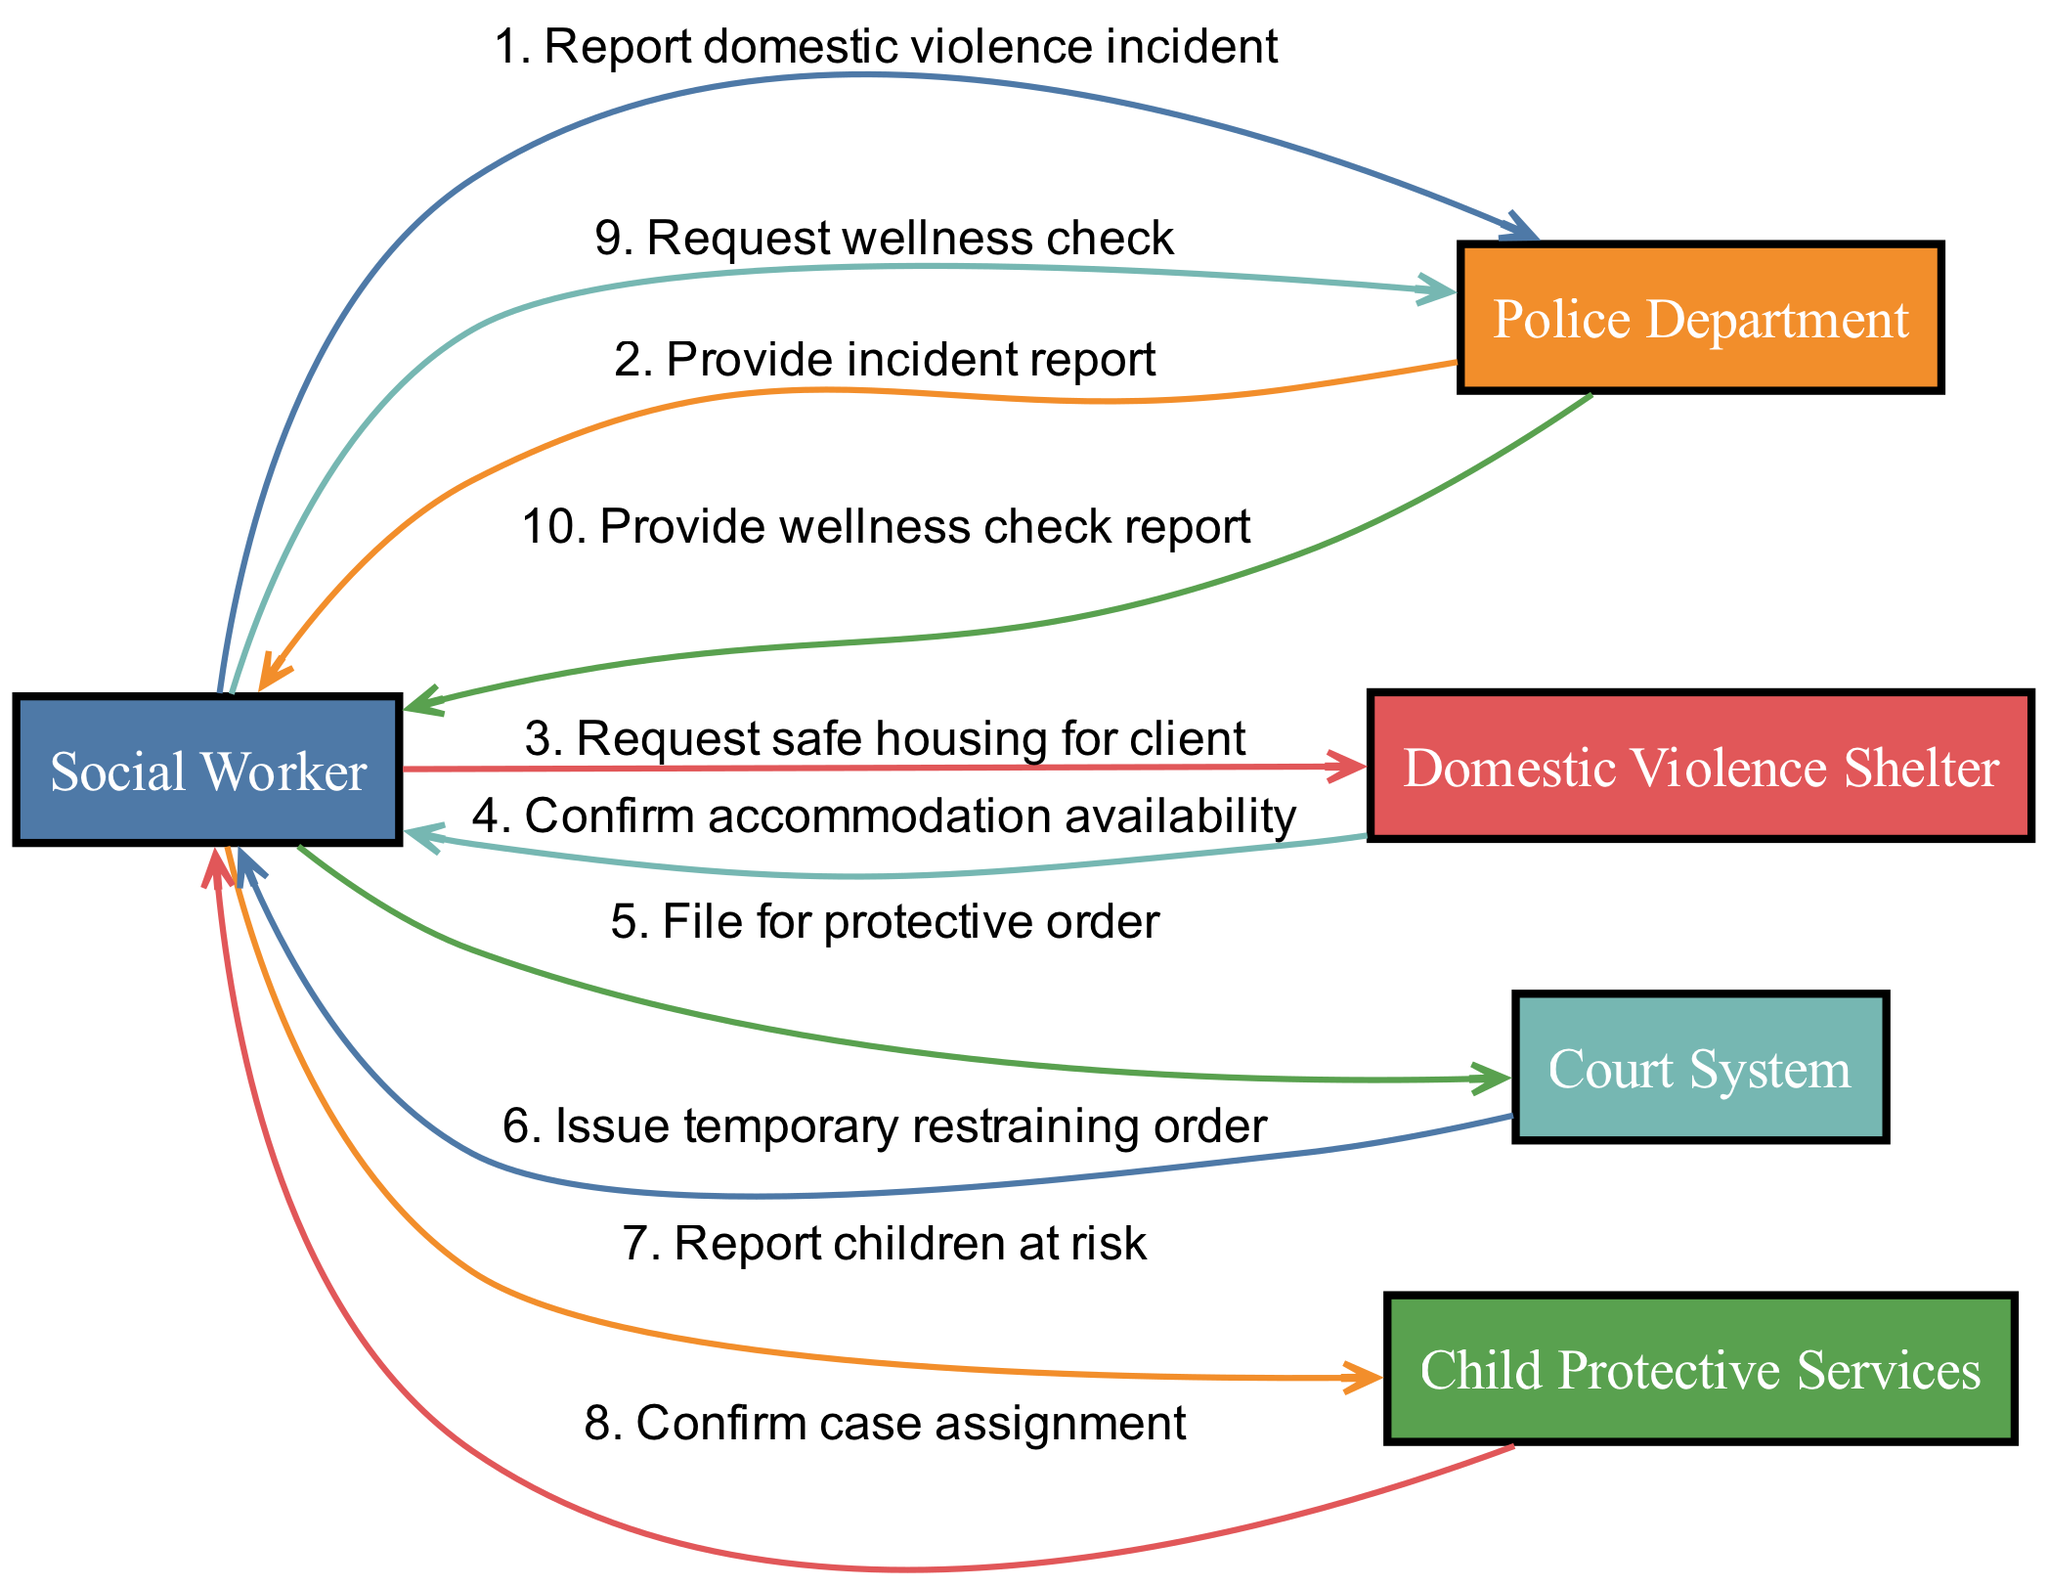What are the actors involved in the diagram? The diagram lists five actors: Social Worker, Police Department, Domestic Violence Shelter, Court System, and Child Protective Services.
Answer: Social Worker, Police Department, Domestic Violence Shelter, Court System, Child Protective Services How many interactions are there in total? The diagram shows a total of ten interactions between the actors. Each interaction is represented by an edge in the diagram.
Answer: 10 What does the Social Worker request from the Domestic Violence Shelter? The interaction indicates that the Social Worker requests safe housing for the client from the Domestic Violence Shelter.
Answer: Request safe housing for client Which actor confirms the case assignment? The diagram shows that Child Protective Services confirms the case assignment to the Social Worker.
Answer: Child Protective Services What is the first action taken by the Social Worker? According to the diagram, the first action taken by the Social Worker is to report a domestic violence incident to the Police Department.
Answer: Report domestic violence incident Which actor issues a temporary restraining order? The Court System is responsible for issuing the temporary restraining order as indicated in the interaction between the Court System and the Social Worker.
Answer: Court System Which two actors are directly connected by the request for a wellness check? The Social Worker requests a wellness check from the Police Department, creating a direct connection for this interaction.
Answer: Social Worker and Police Department What is the last reported action in the sequence? The last action recorded in the sequence is the Police Department providing the wellness check report back to the Social Worker.
Answer: Provide wellness check report How does the flow of communication progress after the Police Department's incident report is provided? After the Police Department provides the incident report, the next action is for the Social Worker to request safe housing from the Domestic Violence Shelter, indicating a collaborative process.
Answer: Request safe housing for client 